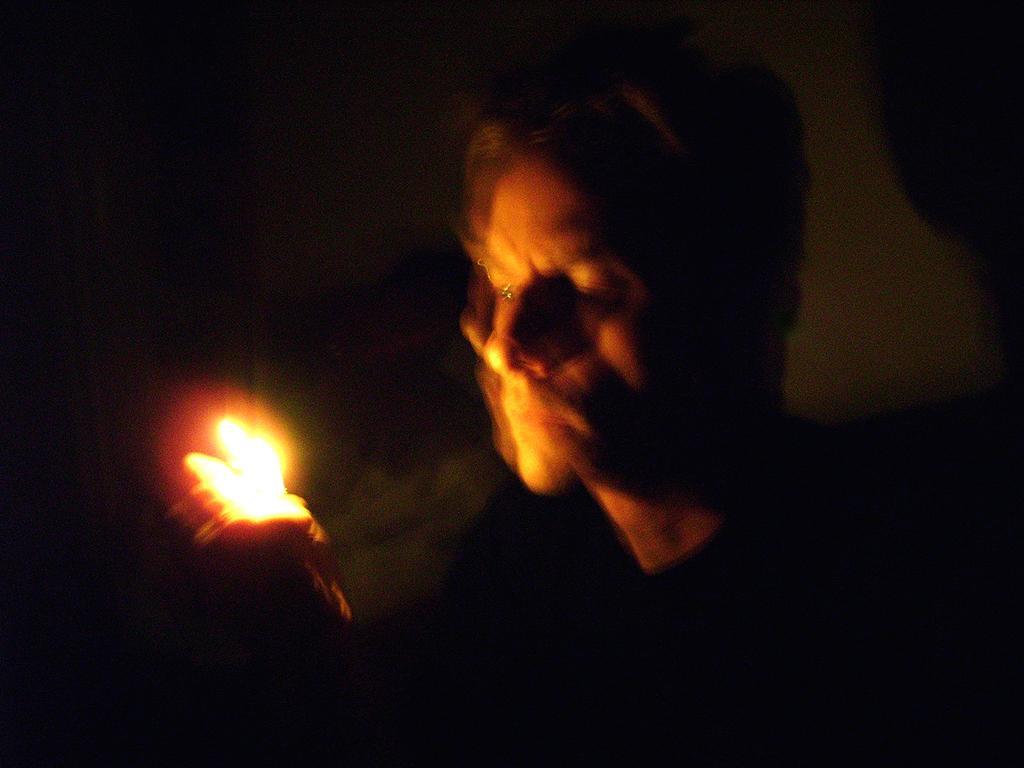Could you give a brief overview of what you see in this image? In this picture we can see one person holding the light in the hands. 